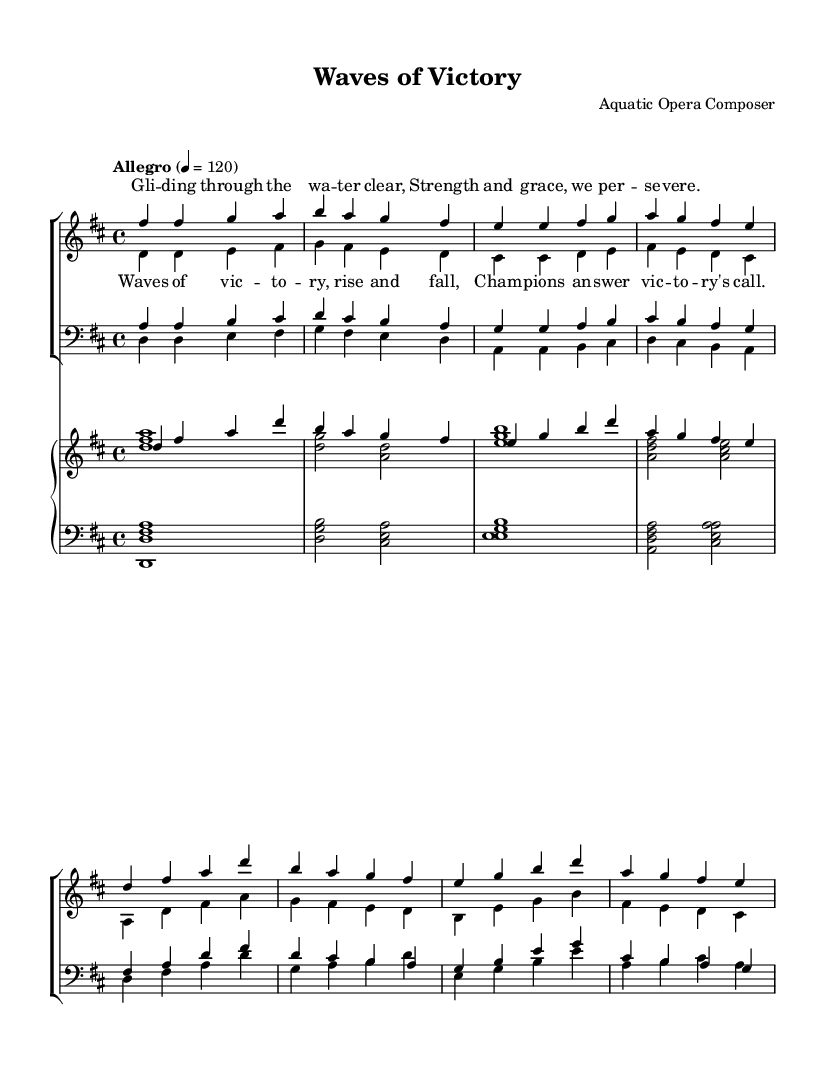What is the key signature of this music? The key signature is indicated by the number of sharps or flats at the beginning of the staff. In this case, the presence of two sharps shows that it is in D major.
Answer: D major What is the time signature of this music? The time signature is found at the beginning of the score where a fraction indicates the beats per measure. Here, it is 4/4, meaning four beats in each measure.
Answer: 4/4 What is the tempo marking for this piece? The tempo is indicated at the beginning, stating "Allegro" along with a metronome marking of quarter note equals 120, suggesting a fast pace.
Answer: Allegro How many sections are present in the piece? By analyzing the structure laid out in the score, we can see separate vocal verses and choruses for sopranos, altos, tenors, and basses, indicating there are two distinct sections per voice type for both verses and choruses.
Answer: 4 What is the title of this opera composition? The title is found in the header section of the sheet music at the top of the score, which directly states the name of the work as "Waves of Victory."
Answer: Waves of Victory What phrase is repeated in the chorus? By looking at the lyrics written under the scored music, the chorus includes the repeated phrase "Waves of victory" in its opening line.
Answer: Waves of victory What are the vocal parts included in this piece? The vocal parts are indicated in the staff labels within the score. They are divided into soprano, alto, tenor, and bass sections, representing the full choir structure.
Answer: Soprano, Alto, Tenor, Bass 